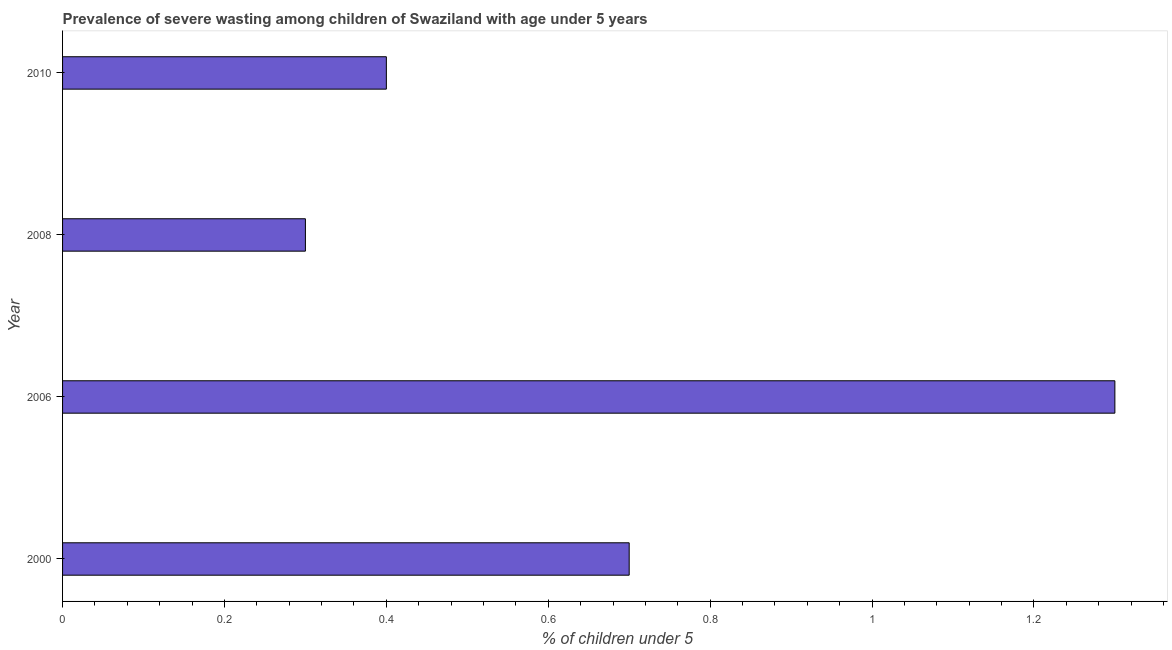Does the graph contain any zero values?
Ensure brevity in your answer.  No. What is the title of the graph?
Ensure brevity in your answer.  Prevalence of severe wasting among children of Swaziland with age under 5 years. What is the label or title of the X-axis?
Offer a very short reply.  % of children under 5. What is the prevalence of severe wasting in 2006?
Your answer should be compact. 1.3. Across all years, what is the maximum prevalence of severe wasting?
Your answer should be compact. 1.3. Across all years, what is the minimum prevalence of severe wasting?
Offer a terse response. 0.3. In which year was the prevalence of severe wasting maximum?
Your response must be concise. 2006. In which year was the prevalence of severe wasting minimum?
Your answer should be compact. 2008. What is the sum of the prevalence of severe wasting?
Make the answer very short. 2.7. What is the average prevalence of severe wasting per year?
Your response must be concise. 0.68. What is the median prevalence of severe wasting?
Offer a very short reply. 0.55. What is the ratio of the prevalence of severe wasting in 2000 to that in 2006?
Provide a short and direct response. 0.54. Is the difference between the prevalence of severe wasting in 2000 and 2010 greater than the difference between any two years?
Provide a short and direct response. No. What is the difference between the highest and the second highest prevalence of severe wasting?
Ensure brevity in your answer.  0.6. Is the sum of the prevalence of severe wasting in 2006 and 2010 greater than the maximum prevalence of severe wasting across all years?
Your response must be concise. Yes. What is the difference between the highest and the lowest prevalence of severe wasting?
Your answer should be very brief. 1. Are all the bars in the graph horizontal?
Ensure brevity in your answer.  Yes. How many years are there in the graph?
Offer a terse response. 4. What is the  % of children under 5 of 2000?
Give a very brief answer. 0.7. What is the  % of children under 5 in 2006?
Ensure brevity in your answer.  1.3. What is the  % of children under 5 of 2008?
Provide a succinct answer. 0.3. What is the  % of children under 5 of 2010?
Ensure brevity in your answer.  0.4. What is the difference between the  % of children under 5 in 2000 and 2008?
Offer a very short reply. 0.4. What is the difference between the  % of children under 5 in 2006 and 2010?
Give a very brief answer. 0.9. What is the difference between the  % of children under 5 in 2008 and 2010?
Offer a very short reply. -0.1. What is the ratio of the  % of children under 5 in 2000 to that in 2006?
Make the answer very short. 0.54. What is the ratio of the  % of children under 5 in 2000 to that in 2008?
Offer a terse response. 2.33. What is the ratio of the  % of children under 5 in 2006 to that in 2008?
Give a very brief answer. 4.33. What is the ratio of the  % of children under 5 in 2006 to that in 2010?
Provide a short and direct response. 3.25. What is the ratio of the  % of children under 5 in 2008 to that in 2010?
Provide a succinct answer. 0.75. 